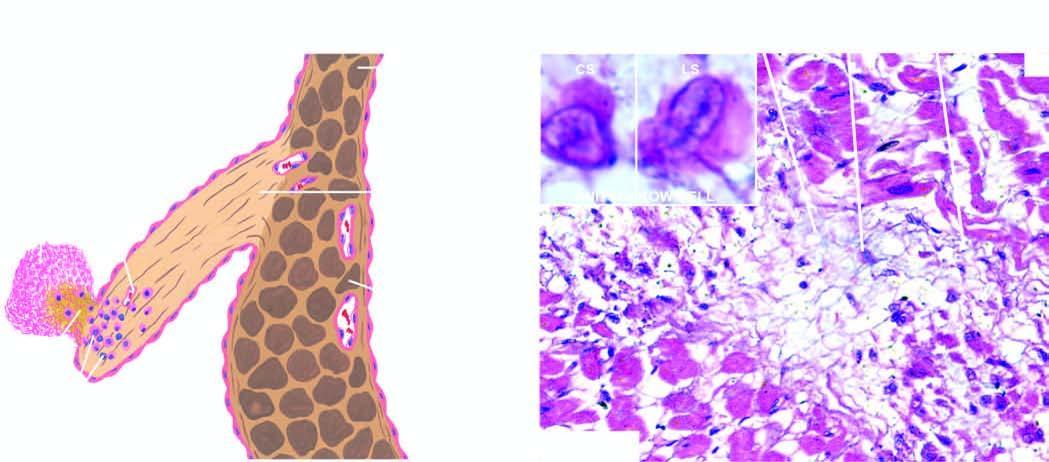where does inbox show an anitschkow cell?
Answer the question using a single word or phrase. In cross section and in longitudinal section 